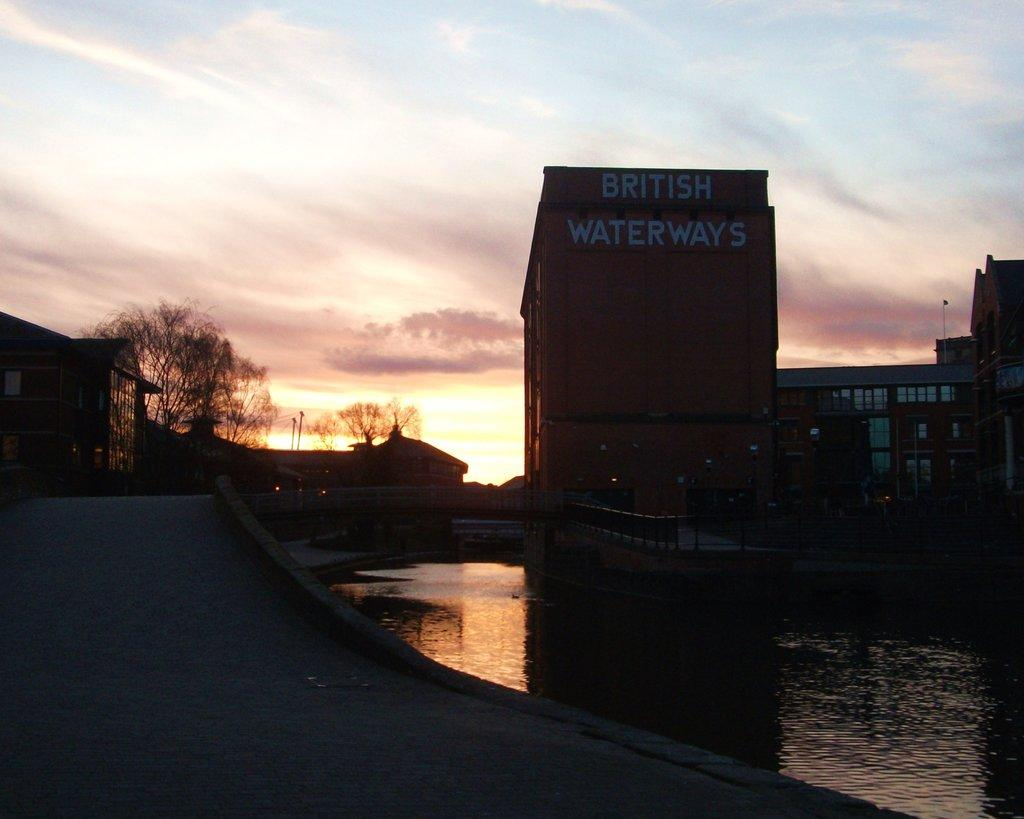What is the primary element present in the image? There is water in the image. What structure can be seen crossing over the water? There is a bridge in the image. What type of vegetation is visible in the image? There are trees in the image. What type of human-made structures can be seen in the image? There are houses and buildings in the image. What type of barrier is present in the image? There is a fence in the image. What additional object can be seen in the image? There is a board in the image. What part of the natural environment is visible in the image? The sky is visible in the image. Based on the lighting and shadows, what time of day might the image have been taken? The image may have been taken in the evening. How many passengers are visible on the board in the image? There are no passengers present on the board in the image. What shape is the water in the image? The water in the image does not have a specific shape; it is a natural body of water. 